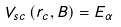<formula> <loc_0><loc_0><loc_500><loc_500>V _ { s c } \left ( r _ { c } , B \right ) = E _ { \alpha }</formula> 